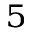<formula> <loc_0><loc_0><loc_500><loc_500>^ { 5 }</formula> 